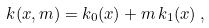<formula> <loc_0><loc_0><loc_500><loc_500>k ( x , m ) = k _ { 0 } ( x ) + m \, k _ { 1 } ( x ) \, ,</formula> 